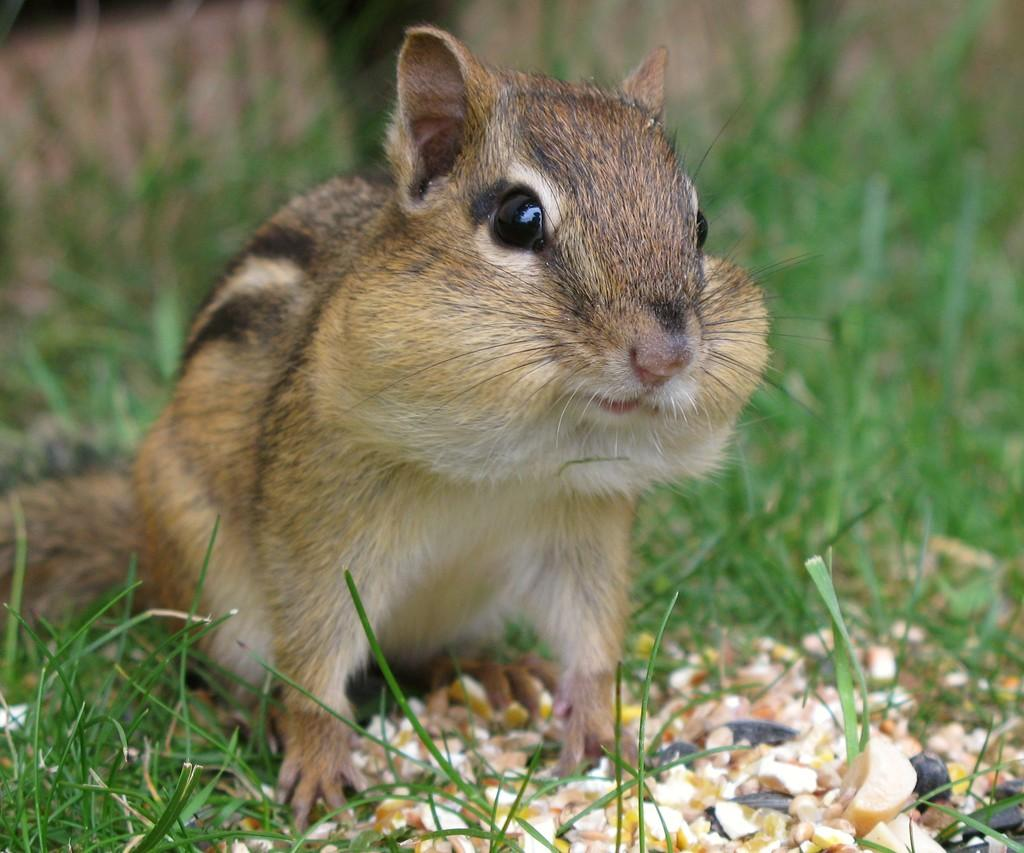What type of animal is present in the image? There is a squirrel in the image. What is the color of the squirrel? The squirrel is brown in color. What type of vegetation is visible in the image? There is grass visible in the image. What is the color of the grass? The grass is green in color. What type of church is present in the image? There is no church present in the image; it features a squirrel and grass. What decisions is the committee making in the image? There is no committee present in the image, as it only shows a squirrel and grass. 